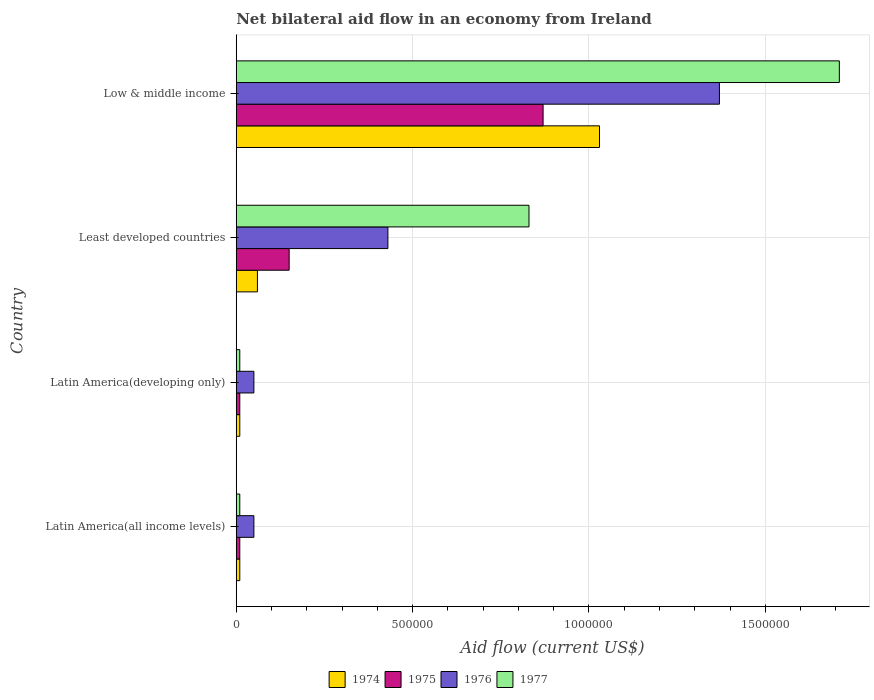How many groups of bars are there?
Your answer should be very brief. 4. Are the number of bars per tick equal to the number of legend labels?
Offer a terse response. Yes. Are the number of bars on each tick of the Y-axis equal?
Your response must be concise. Yes. How many bars are there on the 4th tick from the top?
Your response must be concise. 4. How many bars are there on the 3rd tick from the bottom?
Your answer should be very brief. 4. What is the label of the 4th group of bars from the top?
Offer a terse response. Latin America(all income levels). What is the net bilateral aid flow in 1974 in Low & middle income?
Your answer should be compact. 1.03e+06. Across all countries, what is the maximum net bilateral aid flow in 1976?
Offer a very short reply. 1.37e+06. Across all countries, what is the minimum net bilateral aid flow in 1974?
Keep it short and to the point. 10000. In which country was the net bilateral aid flow in 1974 maximum?
Your answer should be very brief. Low & middle income. In which country was the net bilateral aid flow in 1974 minimum?
Your answer should be very brief. Latin America(all income levels). What is the total net bilateral aid flow in 1977 in the graph?
Your answer should be compact. 2.56e+06. What is the difference between the net bilateral aid flow in 1976 in Least developed countries and that in Low & middle income?
Offer a terse response. -9.40e+05. What is the difference between the net bilateral aid flow in 1976 in Least developed countries and the net bilateral aid flow in 1977 in Low & middle income?
Offer a very short reply. -1.28e+06. What is the average net bilateral aid flow in 1975 per country?
Provide a short and direct response. 2.60e+05. Is the net bilateral aid flow in 1975 in Latin America(developing only) less than that in Least developed countries?
Your response must be concise. Yes. What is the difference between the highest and the second highest net bilateral aid flow in 1975?
Make the answer very short. 7.20e+05. What is the difference between the highest and the lowest net bilateral aid flow in 1975?
Keep it short and to the point. 8.60e+05. In how many countries, is the net bilateral aid flow in 1977 greater than the average net bilateral aid flow in 1977 taken over all countries?
Your answer should be very brief. 2. What does the 4th bar from the top in Least developed countries represents?
Offer a very short reply. 1974. What is the difference between two consecutive major ticks on the X-axis?
Keep it short and to the point. 5.00e+05. Are the values on the major ticks of X-axis written in scientific E-notation?
Provide a succinct answer. No. Where does the legend appear in the graph?
Give a very brief answer. Bottom center. What is the title of the graph?
Ensure brevity in your answer.  Net bilateral aid flow in an economy from Ireland. What is the Aid flow (current US$) in 1977 in Latin America(developing only)?
Your answer should be compact. 10000. What is the Aid flow (current US$) of 1974 in Least developed countries?
Your answer should be very brief. 6.00e+04. What is the Aid flow (current US$) of 1975 in Least developed countries?
Ensure brevity in your answer.  1.50e+05. What is the Aid flow (current US$) in 1977 in Least developed countries?
Make the answer very short. 8.30e+05. What is the Aid flow (current US$) of 1974 in Low & middle income?
Your response must be concise. 1.03e+06. What is the Aid flow (current US$) of 1975 in Low & middle income?
Give a very brief answer. 8.70e+05. What is the Aid flow (current US$) of 1976 in Low & middle income?
Your answer should be compact. 1.37e+06. What is the Aid flow (current US$) in 1977 in Low & middle income?
Offer a very short reply. 1.71e+06. Across all countries, what is the maximum Aid flow (current US$) in 1974?
Provide a short and direct response. 1.03e+06. Across all countries, what is the maximum Aid flow (current US$) in 1975?
Your response must be concise. 8.70e+05. Across all countries, what is the maximum Aid flow (current US$) of 1976?
Your response must be concise. 1.37e+06. Across all countries, what is the maximum Aid flow (current US$) in 1977?
Provide a succinct answer. 1.71e+06. Across all countries, what is the minimum Aid flow (current US$) in 1974?
Offer a very short reply. 10000. Across all countries, what is the minimum Aid flow (current US$) in 1976?
Make the answer very short. 5.00e+04. Across all countries, what is the minimum Aid flow (current US$) of 1977?
Your answer should be compact. 10000. What is the total Aid flow (current US$) of 1974 in the graph?
Ensure brevity in your answer.  1.11e+06. What is the total Aid flow (current US$) of 1975 in the graph?
Offer a terse response. 1.04e+06. What is the total Aid flow (current US$) of 1976 in the graph?
Offer a terse response. 1.90e+06. What is the total Aid flow (current US$) in 1977 in the graph?
Provide a succinct answer. 2.56e+06. What is the difference between the Aid flow (current US$) in 1974 in Latin America(all income levels) and that in Latin America(developing only)?
Your answer should be very brief. 0. What is the difference between the Aid flow (current US$) in 1977 in Latin America(all income levels) and that in Latin America(developing only)?
Offer a very short reply. 0. What is the difference between the Aid flow (current US$) in 1976 in Latin America(all income levels) and that in Least developed countries?
Ensure brevity in your answer.  -3.80e+05. What is the difference between the Aid flow (current US$) of 1977 in Latin America(all income levels) and that in Least developed countries?
Keep it short and to the point. -8.20e+05. What is the difference between the Aid flow (current US$) in 1974 in Latin America(all income levels) and that in Low & middle income?
Your answer should be very brief. -1.02e+06. What is the difference between the Aid flow (current US$) in 1975 in Latin America(all income levels) and that in Low & middle income?
Offer a very short reply. -8.60e+05. What is the difference between the Aid flow (current US$) in 1976 in Latin America(all income levels) and that in Low & middle income?
Your answer should be compact. -1.32e+06. What is the difference between the Aid flow (current US$) in 1977 in Latin America(all income levels) and that in Low & middle income?
Provide a short and direct response. -1.70e+06. What is the difference between the Aid flow (current US$) in 1974 in Latin America(developing only) and that in Least developed countries?
Your answer should be compact. -5.00e+04. What is the difference between the Aid flow (current US$) of 1975 in Latin America(developing only) and that in Least developed countries?
Provide a short and direct response. -1.40e+05. What is the difference between the Aid flow (current US$) of 1976 in Latin America(developing only) and that in Least developed countries?
Keep it short and to the point. -3.80e+05. What is the difference between the Aid flow (current US$) in 1977 in Latin America(developing only) and that in Least developed countries?
Your response must be concise. -8.20e+05. What is the difference between the Aid flow (current US$) in 1974 in Latin America(developing only) and that in Low & middle income?
Your response must be concise. -1.02e+06. What is the difference between the Aid flow (current US$) of 1975 in Latin America(developing only) and that in Low & middle income?
Offer a terse response. -8.60e+05. What is the difference between the Aid flow (current US$) in 1976 in Latin America(developing only) and that in Low & middle income?
Provide a short and direct response. -1.32e+06. What is the difference between the Aid flow (current US$) of 1977 in Latin America(developing only) and that in Low & middle income?
Provide a succinct answer. -1.70e+06. What is the difference between the Aid flow (current US$) of 1974 in Least developed countries and that in Low & middle income?
Offer a very short reply. -9.70e+05. What is the difference between the Aid flow (current US$) of 1975 in Least developed countries and that in Low & middle income?
Your response must be concise. -7.20e+05. What is the difference between the Aid flow (current US$) of 1976 in Least developed countries and that in Low & middle income?
Offer a terse response. -9.40e+05. What is the difference between the Aid flow (current US$) in 1977 in Least developed countries and that in Low & middle income?
Provide a short and direct response. -8.80e+05. What is the difference between the Aid flow (current US$) in 1974 in Latin America(all income levels) and the Aid flow (current US$) in 1977 in Latin America(developing only)?
Your answer should be very brief. 0. What is the difference between the Aid flow (current US$) of 1975 in Latin America(all income levels) and the Aid flow (current US$) of 1976 in Latin America(developing only)?
Provide a short and direct response. -4.00e+04. What is the difference between the Aid flow (current US$) in 1974 in Latin America(all income levels) and the Aid flow (current US$) in 1975 in Least developed countries?
Your answer should be compact. -1.40e+05. What is the difference between the Aid flow (current US$) in 1974 in Latin America(all income levels) and the Aid flow (current US$) in 1976 in Least developed countries?
Offer a terse response. -4.20e+05. What is the difference between the Aid flow (current US$) of 1974 in Latin America(all income levels) and the Aid flow (current US$) of 1977 in Least developed countries?
Your response must be concise. -8.20e+05. What is the difference between the Aid flow (current US$) in 1975 in Latin America(all income levels) and the Aid flow (current US$) in 1976 in Least developed countries?
Provide a short and direct response. -4.20e+05. What is the difference between the Aid flow (current US$) of 1975 in Latin America(all income levels) and the Aid flow (current US$) of 1977 in Least developed countries?
Provide a short and direct response. -8.20e+05. What is the difference between the Aid flow (current US$) in 1976 in Latin America(all income levels) and the Aid flow (current US$) in 1977 in Least developed countries?
Your answer should be compact. -7.80e+05. What is the difference between the Aid flow (current US$) in 1974 in Latin America(all income levels) and the Aid flow (current US$) in 1975 in Low & middle income?
Give a very brief answer. -8.60e+05. What is the difference between the Aid flow (current US$) in 1974 in Latin America(all income levels) and the Aid flow (current US$) in 1976 in Low & middle income?
Offer a terse response. -1.36e+06. What is the difference between the Aid flow (current US$) of 1974 in Latin America(all income levels) and the Aid flow (current US$) of 1977 in Low & middle income?
Your response must be concise. -1.70e+06. What is the difference between the Aid flow (current US$) of 1975 in Latin America(all income levels) and the Aid flow (current US$) of 1976 in Low & middle income?
Offer a terse response. -1.36e+06. What is the difference between the Aid flow (current US$) in 1975 in Latin America(all income levels) and the Aid flow (current US$) in 1977 in Low & middle income?
Make the answer very short. -1.70e+06. What is the difference between the Aid flow (current US$) in 1976 in Latin America(all income levels) and the Aid flow (current US$) in 1977 in Low & middle income?
Keep it short and to the point. -1.66e+06. What is the difference between the Aid flow (current US$) of 1974 in Latin America(developing only) and the Aid flow (current US$) of 1975 in Least developed countries?
Make the answer very short. -1.40e+05. What is the difference between the Aid flow (current US$) of 1974 in Latin America(developing only) and the Aid flow (current US$) of 1976 in Least developed countries?
Keep it short and to the point. -4.20e+05. What is the difference between the Aid flow (current US$) of 1974 in Latin America(developing only) and the Aid flow (current US$) of 1977 in Least developed countries?
Your response must be concise. -8.20e+05. What is the difference between the Aid flow (current US$) of 1975 in Latin America(developing only) and the Aid flow (current US$) of 1976 in Least developed countries?
Offer a very short reply. -4.20e+05. What is the difference between the Aid flow (current US$) in 1975 in Latin America(developing only) and the Aid flow (current US$) in 1977 in Least developed countries?
Make the answer very short. -8.20e+05. What is the difference between the Aid flow (current US$) of 1976 in Latin America(developing only) and the Aid flow (current US$) of 1977 in Least developed countries?
Provide a succinct answer. -7.80e+05. What is the difference between the Aid flow (current US$) in 1974 in Latin America(developing only) and the Aid flow (current US$) in 1975 in Low & middle income?
Offer a terse response. -8.60e+05. What is the difference between the Aid flow (current US$) of 1974 in Latin America(developing only) and the Aid flow (current US$) of 1976 in Low & middle income?
Make the answer very short. -1.36e+06. What is the difference between the Aid flow (current US$) in 1974 in Latin America(developing only) and the Aid flow (current US$) in 1977 in Low & middle income?
Provide a succinct answer. -1.70e+06. What is the difference between the Aid flow (current US$) of 1975 in Latin America(developing only) and the Aid flow (current US$) of 1976 in Low & middle income?
Provide a short and direct response. -1.36e+06. What is the difference between the Aid flow (current US$) in 1975 in Latin America(developing only) and the Aid flow (current US$) in 1977 in Low & middle income?
Provide a succinct answer. -1.70e+06. What is the difference between the Aid flow (current US$) of 1976 in Latin America(developing only) and the Aid flow (current US$) of 1977 in Low & middle income?
Provide a short and direct response. -1.66e+06. What is the difference between the Aid flow (current US$) of 1974 in Least developed countries and the Aid flow (current US$) of 1975 in Low & middle income?
Offer a terse response. -8.10e+05. What is the difference between the Aid flow (current US$) in 1974 in Least developed countries and the Aid flow (current US$) in 1976 in Low & middle income?
Your answer should be very brief. -1.31e+06. What is the difference between the Aid flow (current US$) in 1974 in Least developed countries and the Aid flow (current US$) in 1977 in Low & middle income?
Your answer should be very brief. -1.65e+06. What is the difference between the Aid flow (current US$) in 1975 in Least developed countries and the Aid flow (current US$) in 1976 in Low & middle income?
Give a very brief answer. -1.22e+06. What is the difference between the Aid flow (current US$) in 1975 in Least developed countries and the Aid flow (current US$) in 1977 in Low & middle income?
Your answer should be compact. -1.56e+06. What is the difference between the Aid flow (current US$) of 1976 in Least developed countries and the Aid flow (current US$) of 1977 in Low & middle income?
Make the answer very short. -1.28e+06. What is the average Aid flow (current US$) of 1974 per country?
Make the answer very short. 2.78e+05. What is the average Aid flow (current US$) in 1975 per country?
Ensure brevity in your answer.  2.60e+05. What is the average Aid flow (current US$) of 1976 per country?
Ensure brevity in your answer.  4.75e+05. What is the average Aid flow (current US$) in 1977 per country?
Your answer should be very brief. 6.40e+05. What is the difference between the Aid flow (current US$) of 1974 and Aid flow (current US$) of 1976 in Latin America(all income levels)?
Offer a terse response. -4.00e+04. What is the difference between the Aid flow (current US$) in 1975 and Aid flow (current US$) in 1976 in Latin America(all income levels)?
Provide a short and direct response. -4.00e+04. What is the difference between the Aid flow (current US$) of 1976 and Aid flow (current US$) of 1977 in Latin America(all income levels)?
Provide a succinct answer. 4.00e+04. What is the difference between the Aid flow (current US$) in 1974 and Aid flow (current US$) in 1975 in Latin America(developing only)?
Ensure brevity in your answer.  0. What is the difference between the Aid flow (current US$) in 1974 and Aid flow (current US$) in 1977 in Latin America(developing only)?
Ensure brevity in your answer.  0. What is the difference between the Aid flow (current US$) of 1975 and Aid flow (current US$) of 1976 in Latin America(developing only)?
Make the answer very short. -4.00e+04. What is the difference between the Aid flow (current US$) in 1976 and Aid flow (current US$) in 1977 in Latin America(developing only)?
Your response must be concise. 4.00e+04. What is the difference between the Aid flow (current US$) of 1974 and Aid flow (current US$) of 1975 in Least developed countries?
Provide a succinct answer. -9.00e+04. What is the difference between the Aid flow (current US$) of 1974 and Aid flow (current US$) of 1976 in Least developed countries?
Make the answer very short. -3.70e+05. What is the difference between the Aid flow (current US$) in 1974 and Aid flow (current US$) in 1977 in Least developed countries?
Provide a succinct answer. -7.70e+05. What is the difference between the Aid flow (current US$) of 1975 and Aid flow (current US$) of 1976 in Least developed countries?
Your response must be concise. -2.80e+05. What is the difference between the Aid flow (current US$) of 1975 and Aid flow (current US$) of 1977 in Least developed countries?
Your answer should be compact. -6.80e+05. What is the difference between the Aid flow (current US$) of 1976 and Aid flow (current US$) of 1977 in Least developed countries?
Give a very brief answer. -4.00e+05. What is the difference between the Aid flow (current US$) of 1974 and Aid flow (current US$) of 1977 in Low & middle income?
Make the answer very short. -6.80e+05. What is the difference between the Aid flow (current US$) in 1975 and Aid flow (current US$) in 1976 in Low & middle income?
Give a very brief answer. -5.00e+05. What is the difference between the Aid flow (current US$) in 1975 and Aid flow (current US$) in 1977 in Low & middle income?
Offer a terse response. -8.40e+05. What is the ratio of the Aid flow (current US$) in 1976 in Latin America(all income levels) to that in Latin America(developing only)?
Make the answer very short. 1. What is the ratio of the Aid flow (current US$) of 1974 in Latin America(all income levels) to that in Least developed countries?
Ensure brevity in your answer.  0.17. What is the ratio of the Aid flow (current US$) in 1975 in Latin America(all income levels) to that in Least developed countries?
Your answer should be very brief. 0.07. What is the ratio of the Aid flow (current US$) in 1976 in Latin America(all income levels) to that in Least developed countries?
Keep it short and to the point. 0.12. What is the ratio of the Aid flow (current US$) of 1977 in Latin America(all income levels) to that in Least developed countries?
Give a very brief answer. 0.01. What is the ratio of the Aid flow (current US$) in 1974 in Latin America(all income levels) to that in Low & middle income?
Your response must be concise. 0.01. What is the ratio of the Aid flow (current US$) in 1975 in Latin America(all income levels) to that in Low & middle income?
Offer a very short reply. 0.01. What is the ratio of the Aid flow (current US$) in 1976 in Latin America(all income levels) to that in Low & middle income?
Offer a very short reply. 0.04. What is the ratio of the Aid flow (current US$) in 1977 in Latin America(all income levels) to that in Low & middle income?
Offer a terse response. 0.01. What is the ratio of the Aid flow (current US$) in 1974 in Latin America(developing only) to that in Least developed countries?
Provide a succinct answer. 0.17. What is the ratio of the Aid flow (current US$) in 1975 in Latin America(developing only) to that in Least developed countries?
Provide a short and direct response. 0.07. What is the ratio of the Aid flow (current US$) of 1976 in Latin America(developing only) to that in Least developed countries?
Keep it short and to the point. 0.12. What is the ratio of the Aid flow (current US$) of 1977 in Latin America(developing only) to that in Least developed countries?
Your answer should be very brief. 0.01. What is the ratio of the Aid flow (current US$) of 1974 in Latin America(developing only) to that in Low & middle income?
Provide a short and direct response. 0.01. What is the ratio of the Aid flow (current US$) in 1975 in Latin America(developing only) to that in Low & middle income?
Offer a terse response. 0.01. What is the ratio of the Aid flow (current US$) in 1976 in Latin America(developing only) to that in Low & middle income?
Provide a short and direct response. 0.04. What is the ratio of the Aid flow (current US$) of 1977 in Latin America(developing only) to that in Low & middle income?
Make the answer very short. 0.01. What is the ratio of the Aid flow (current US$) of 1974 in Least developed countries to that in Low & middle income?
Provide a succinct answer. 0.06. What is the ratio of the Aid flow (current US$) in 1975 in Least developed countries to that in Low & middle income?
Keep it short and to the point. 0.17. What is the ratio of the Aid flow (current US$) in 1976 in Least developed countries to that in Low & middle income?
Provide a succinct answer. 0.31. What is the ratio of the Aid flow (current US$) in 1977 in Least developed countries to that in Low & middle income?
Provide a short and direct response. 0.49. What is the difference between the highest and the second highest Aid flow (current US$) of 1974?
Provide a succinct answer. 9.70e+05. What is the difference between the highest and the second highest Aid flow (current US$) of 1975?
Your answer should be compact. 7.20e+05. What is the difference between the highest and the second highest Aid flow (current US$) of 1976?
Ensure brevity in your answer.  9.40e+05. What is the difference between the highest and the second highest Aid flow (current US$) of 1977?
Provide a succinct answer. 8.80e+05. What is the difference between the highest and the lowest Aid flow (current US$) of 1974?
Offer a very short reply. 1.02e+06. What is the difference between the highest and the lowest Aid flow (current US$) in 1975?
Keep it short and to the point. 8.60e+05. What is the difference between the highest and the lowest Aid flow (current US$) in 1976?
Make the answer very short. 1.32e+06. What is the difference between the highest and the lowest Aid flow (current US$) of 1977?
Offer a terse response. 1.70e+06. 